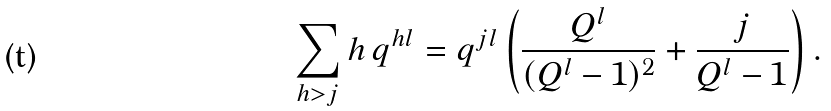Convert formula to latex. <formula><loc_0><loc_0><loc_500><loc_500>\sum _ { h > j } h \, q ^ { h l } = q ^ { j l } \left ( \frac { Q ^ { l } } { ( Q ^ { l } - 1 ) ^ { 2 } } + \frac { j } { Q ^ { l } - 1 } \right ) .</formula> 